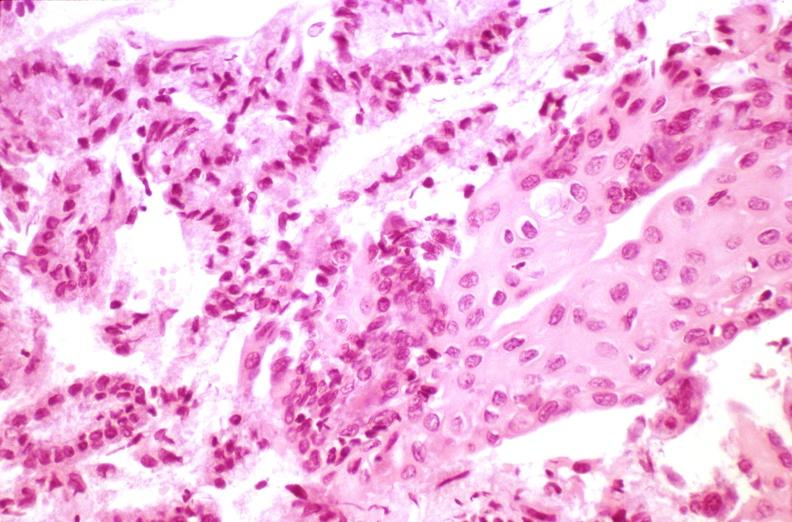does this image show cervix, squamous metaplasia?
Answer the question using a single word or phrase. Yes 